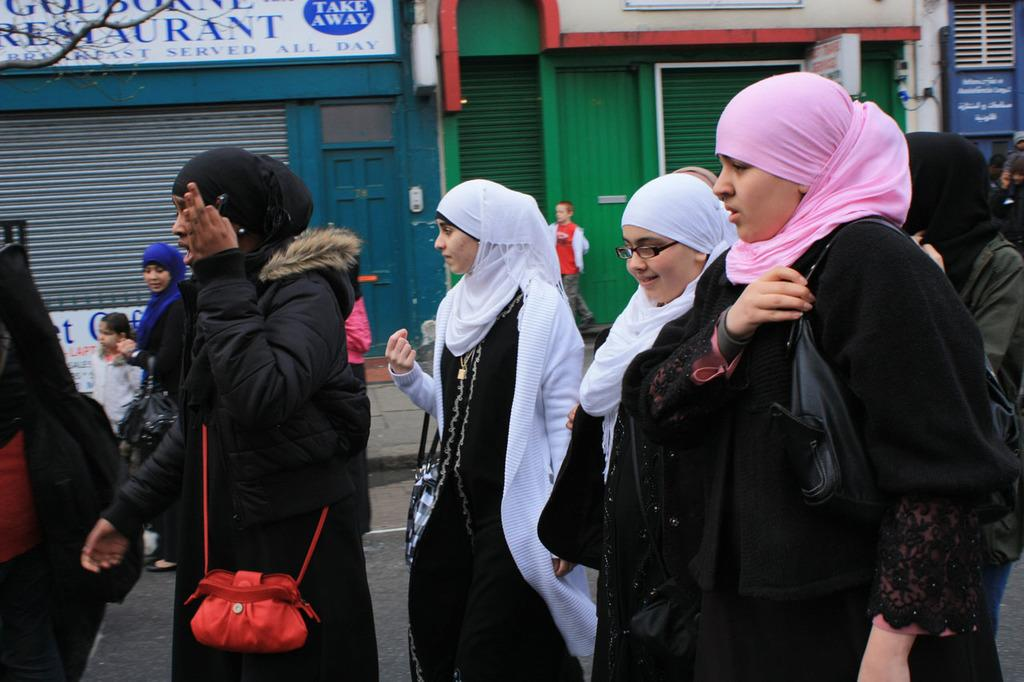Who are the people in the image? There are Muslims in the image. What are the Muslims doing in the image? The Muslims are walking on the road. What are the Muslims wearing in the image? The Muslims are wearing black dress (burkas). What can be seen in the background of the image? There are shops visible in the background of the image. What type of sweater is the farmer wearing in the image? There is no farmer or sweater present in the image. What is the hook used for in the image? There is no hook present in the image. 